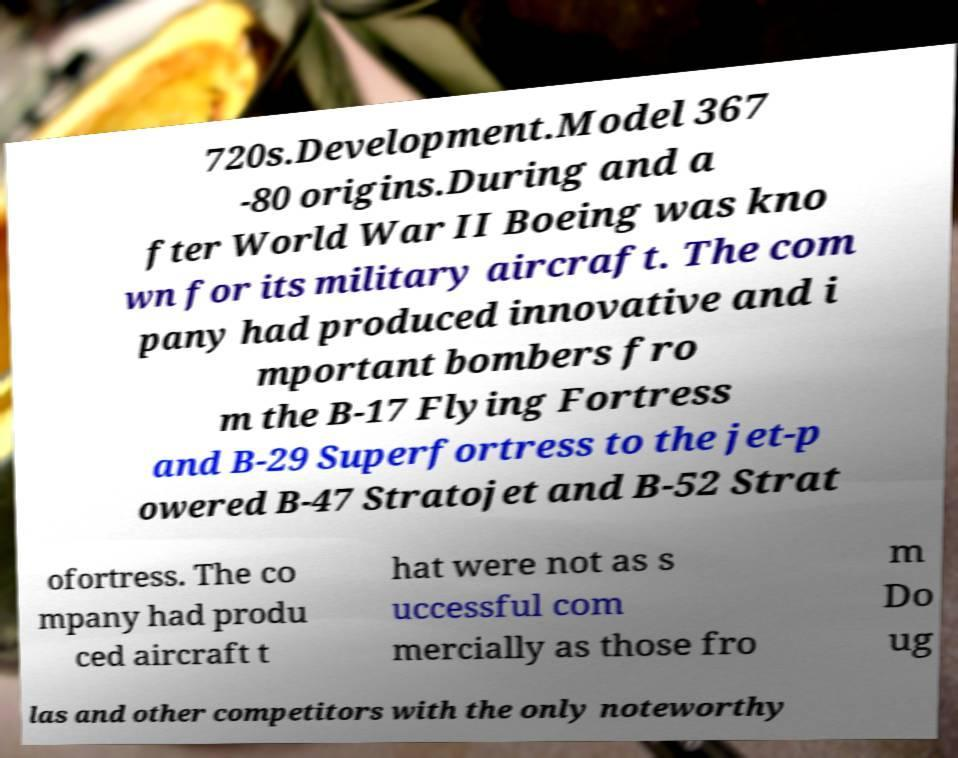Can you accurately transcribe the text from the provided image for me? 720s.Development.Model 367 -80 origins.During and a fter World War II Boeing was kno wn for its military aircraft. The com pany had produced innovative and i mportant bombers fro m the B-17 Flying Fortress and B-29 Superfortress to the jet-p owered B-47 Stratojet and B-52 Strat ofortress. The co mpany had produ ced aircraft t hat were not as s uccessful com mercially as those fro m Do ug las and other competitors with the only noteworthy 